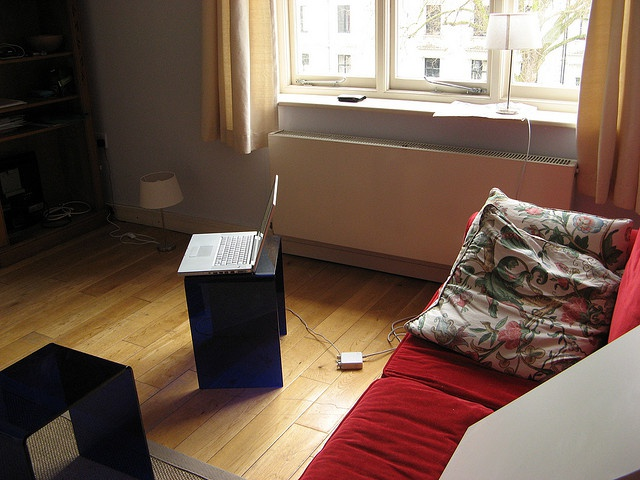Describe the objects in this image and their specific colors. I can see couch in black, maroon, brown, and gray tones, laptop in black, lightgray, darkgray, and gray tones, book in black tones, remote in black, white, and gray tones, and cell phone in black, white, and gray tones in this image. 